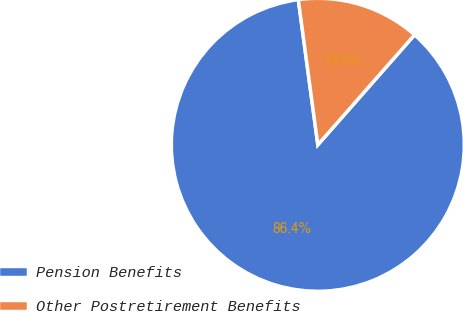Convert chart to OTSL. <chart><loc_0><loc_0><loc_500><loc_500><pie_chart><fcel>Pension Benefits<fcel>Other Postretirement Benefits<nl><fcel>86.39%<fcel>13.61%<nl></chart> 